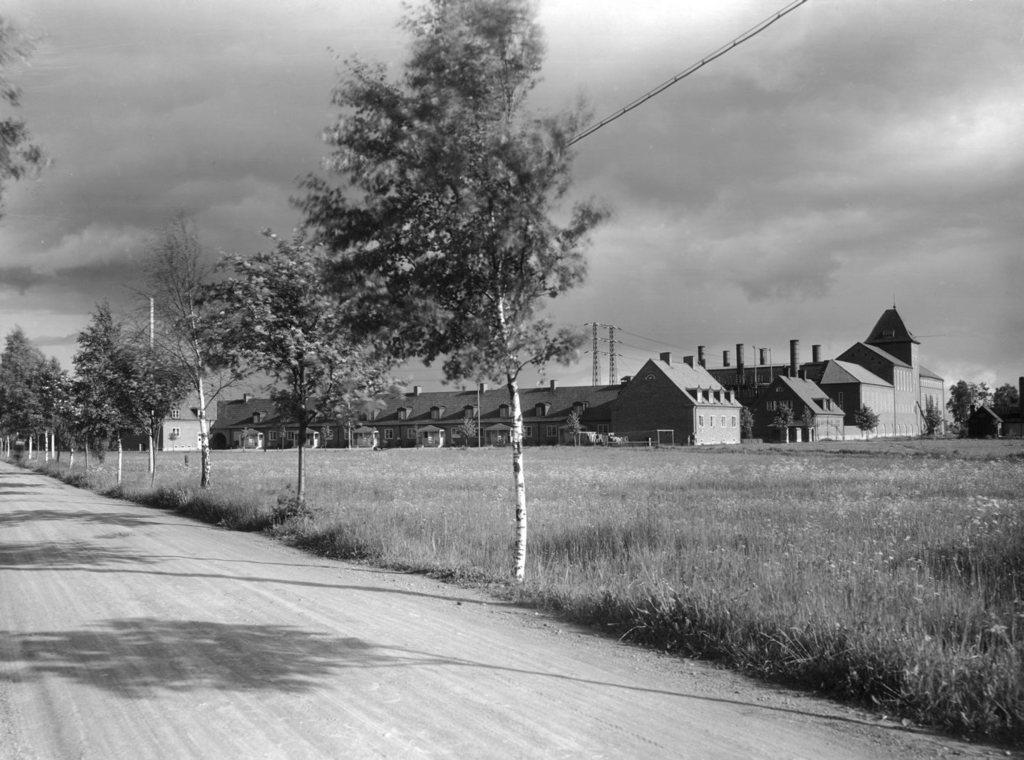What type of landscape is depicted in the center of the image? There is a grassland in the center of the image. What type of structures can be seen in the image? There are houses and towers in the image. What type of vegetation is present in the image? There are trees in the image. What type of copper material can be seen in the image? There is no copper material present in the image. What type of harbor can be seen in the image? There is no harbor present in the image. 